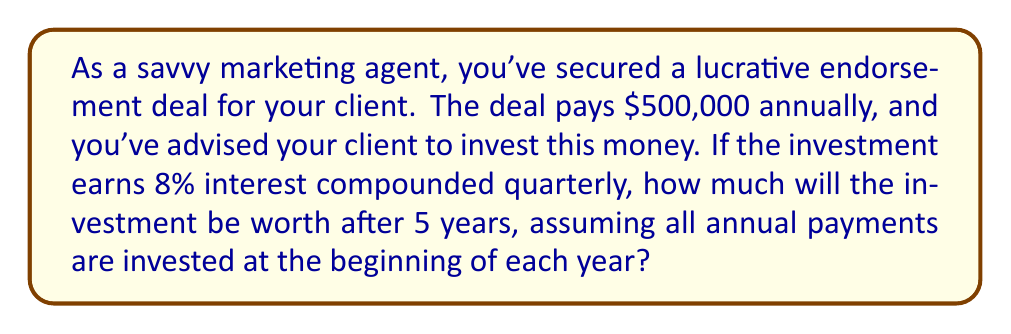What is the answer to this math problem? To solve this problem, we need to use the compound interest formula and consider that we have multiple deposits over time. Let's break it down step-by-step:

1) The compound interest formula is:
   $$A = P(1 + \frac{r}{n})^{nt}$$
   Where:
   $A$ = final amount
   $P$ = principal (initial investment)
   $r$ = annual interest rate (as a decimal)
   $n$ = number of times interest is compounded per year
   $t$ = number of years

2) In this case:
   $r = 0.08$ (8% annual interest)
   $n = 4$ (compounded quarterly)
   $t = 5$ years

3) We need to calculate the future value of each $500,000 payment separately:

   Year 1 payment: $500,000(1 + \frac{0.08}{4})^{4 \cdot 5} = 500,000(1.02)^{20}$
   Year 2 payment: $500,000(1 + \frac{0.08}{4})^{4 \cdot 4} = 500,000(1.02)^{16}$
   Year 3 payment: $500,000(1 + \frac{0.08}{4})^{4 \cdot 3} = 500,000(1.02)^{12}$
   Year 4 payment: $500,000(1 + \frac{0.08}{4})^{4 \cdot 2} = 500,000(1.02)^{8}$
   Year 5 payment: $500,000(1 + \frac{0.08}{4})^{4 \cdot 1} = 500,000(1.02)^{4}$

4) Now, we sum up all these values:

   $$Total = 500,000[(1.02)^{20} + (1.02)^{16} + (1.02)^{12} + (1.02)^{8} + (1.02)^{4}]$$

5) Calculating this:
   $$Total = 500,000[1.485947 + 1.371659 + 1.268242 + 1.174901 + 1.082432]$$
   $$Total = 500,000[6.383181]$$
   $$Total = 3,191,590.50$$

Therefore, after 5 years, the investment will be worth $3,191,590.50.
Answer: $3,191,590.50 